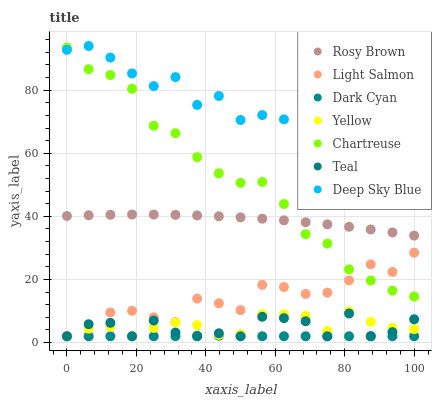Does Dark Cyan have the minimum area under the curve?
Answer yes or no. Yes. Does Deep Sky Blue have the maximum area under the curve?
Answer yes or no. Yes. Does Rosy Brown have the minimum area under the curve?
Answer yes or no. No. Does Rosy Brown have the maximum area under the curve?
Answer yes or no. No. Is Dark Cyan the smoothest?
Answer yes or no. Yes. Is Teal the roughest?
Answer yes or no. Yes. Is Deep Sky Blue the smoothest?
Answer yes or no. No. Is Deep Sky Blue the roughest?
Answer yes or no. No. Does Light Salmon have the lowest value?
Answer yes or no. Yes. Does Rosy Brown have the lowest value?
Answer yes or no. No. Does Deep Sky Blue have the highest value?
Answer yes or no. Yes. Does Rosy Brown have the highest value?
Answer yes or no. No. Is Yellow less than Deep Sky Blue?
Answer yes or no. Yes. Is Rosy Brown greater than Dark Cyan?
Answer yes or no. Yes. Does Teal intersect Yellow?
Answer yes or no. Yes. Is Teal less than Yellow?
Answer yes or no. No. Is Teal greater than Yellow?
Answer yes or no. No. Does Yellow intersect Deep Sky Blue?
Answer yes or no. No. 